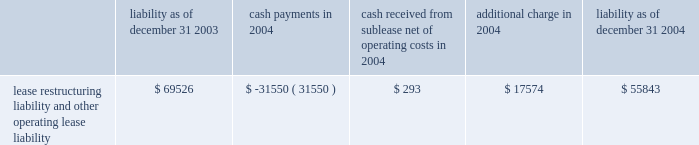The activity related to the restructuring liability for 2004 is as follows ( in thousands ) : non-operating items interest income increased $ 1.7 million to $ 12.0 million in 2005 from $ 10.3 million in 2004 .
The increase was mainly the result of higher returns on invested funds .
Interest expense decreased $ 1.0 million , or 5% ( 5 % ) , to $ 17.3 million in 2005 from $ 18.3 million in 2004 as a result of the exchange of newly issued stock for a portion of our outstanding convertible debt in the second half of 2005 .
In addition , as a result of the issuance during 2005 of common stock in exchange for convertible subordinated notes , we recorded a non- cash charge of $ 48.2 million .
This charge related to the incremental shares issued in the transactions over the number of shares that would have been issued upon the conversion of the notes under their original terms .
Liquidity and capital resources we have incurred operating losses since our inception and historically have financed our operations principally through public and private offerings of our equity and debt securities , strategic collaborative agreements that include research and/or development funding , development milestones and royalties on the sales of products , investment income and proceeds from the issuance of stock under our employee benefit programs .
At december 31 , 2006 , we had cash , cash equivalents and marketable securities of $ 761.8 million , which was an increase of $ 354.2 million from $ 407.5 million at december 31 , 2005 .
The increase was primarily a result of : 2022 $ 313.7 million in net proceeds from our september 2006 public offering of common stock ; 2022 $ 165.0 million from an up-front payment we received in connection with signing the janssen agreement ; 2022 $ 52.4 million from the issuance of common stock under our employee benefit plans ; and 2022 $ 30.0 million from the sale of shares of altus pharmaceuticals inc .
Common stock and warrants to purchase altus common stock .
These cash inflows were partially offset by the significant cash expenditures we made in 2006 related to research and development expenses and sales , general and administrative expenses .
Capital expenditures for property and equipment during 2006 were $ 32.4 million .
At december 31 , 2006 , we had $ 42.1 million in aggregate principal amount of the 2007 notes and $ 59.6 million in aggregate principal amount of the 2011 notes outstanding .
The 2007 notes are due in september 2007 and are convertible into common stock at the option of the holder at a price equal to $ 92.26 per share , subject to adjustment under certain circumstances .
In february 2007 , we announced that we will redeem our 2011 notes on march 5 , 2007 .
The 2011 notes are convertible into shares of our common stock at the option of the holder at a price equal to $ 14.94 per share .
We expect the holders of the 2011 notes will elect to convert their notes into stock , in which case we will issue approximately 4.0 million .
We will be required to repay any 2011 notes that are not converted at the rate of $ 1003.19 per $ 1000 principal amount , which includes principal and interest that will accrue to the redemption date .
Liability as of december 31 , payments in 2004 cash received from sublease , net of operating costs in 2004 additional charge in liability as of december 31 , lease restructuring liability and other operating lease liability $ 69526 $ ( 31550 ) $ 293 $ 17574 $ 55843 .
The activity related to the restructuring liability for 2004 is as follows ( in thousands ) : non-operating items interest income increased $ 1.7 million to $ 12.0 million in 2005 from $ 10.3 million in 2004 .
The increase was mainly the result of higher returns on invested funds .
Interest expense decreased $ 1.0 million , or 5% ( 5 % ) , to $ 17.3 million in 2005 from $ 18.3 million in 2004 as a result of the exchange of newly issued stock for a portion of our outstanding convertible debt in the second half of 2005 .
In addition , as a result of the issuance during 2005 of common stock in exchange for convertible subordinated notes , we recorded a non- cash charge of $ 48.2 million .
This charge related to the incremental shares issued in the transactions over the number of shares that would have been issued upon the conversion of the notes under their original terms .
Liquidity and capital resources we have incurred operating losses since our inception and historically have financed our operations principally through public and private offerings of our equity and debt securities , strategic collaborative agreements that include research and/or development funding , development milestones and royalties on the sales of products , investment income and proceeds from the issuance of stock under our employee benefit programs .
At december 31 , 2006 , we had cash , cash equivalents and marketable securities of $ 761.8 million , which was an increase of $ 354.2 million from $ 407.5 million at december 31 , 2005 .
The increase was primarily a result of : 2022 $ 313.7 million in net proceeds from our september 2006 public offering of common stock ; 2022 $ 165.0 million from an up-front payment we received in connection with signing the janssen agreement ; 2022 $ 52.4 million from the issuance of common stock under our employee benefit plans ; and 2022 $ 30.0 million from the sale of shares of altus pharmaceuticals inc .
Common stock and warrants to purchase altus common stock .
These cash inflows were partially offset by the significant cash expenditures we made in 2006 related to research and development expenses and sales , general and administrative expenses .
Capital expenditures for property and equipment during 2006 were $ 32.4 million .
At december 31 , 2006 , we had $ 42.1 million in aggregate principal amount of the 2007 notes and $ 59.6 million in aggregate principal amount of the 2011 notes outstanding .
The 2007 notes are due in september 2007 and are convertible into common stock at the option of the holder at a price equal to $ 92.26 per share , subject to adjustment under certain circumstances .
In february 2007 , we announced that we will redeem our 2011 notes on march 5 , 2007 .
The 2011 notes are convertible into shares of our common stock at the option of the holder at a price equal to $ 14.94 per share .
We expect the holders of the 2011 notes will elect to convert their notes into stock , in which case we will issue approximately 4.0 million .
We will be required to repay any 2011 notes that are not converted at the rate of $ 1003.19 per $ 1000 principal amount , which includes principal and interest that will accrue to the redemption date .
Liability as of december 31 , payments in 2004 cash received from sublease , net of operating costs in 2004 additional charge in liability as of december 31 , lease restructuring liability and other operating lease liability $ 69526 $ ( 31550 ) $ 293 $ 17574 $ 55843 .
What is the percent change in cash , cash equivalents and marketable securities between 2005 and 2006? 
Rationale: there is something wrong with this sample . i think it is repeated but i'm not sure .
Computations: ((761.8 - 407.5) / 407.5)
Answer: 0.86945. The activity related to the restructuring liability for 2004 is as follows ( in thousands ) : non-operating items interest income increased $ 1.7 million to $ 12.0 million in 2005 from $ 10.3 million in 2004 .
The increase was mainly the result of higher returns on invested funds .
Interest expense decreased $ 1.0 million , or 5% ( 5 % ) , to $ 17.3 million in 2005 from $ 18.3 million in 2004 as a result of the exchange of newly issued stock for a portion of our outstanding convertible debt in the second half of 2005 .
In addition , as a result of the issuance during 2005 of common stock in exchange for convertible subordinated notes , we recorded a non- cash charge of $ 48.2 million .
This charge related to the incremental shares issued in the transactions over the number of shares that would have been issued upon the conversion of the notes under their original terms .
Liquidity and capital resources we have incurred operating losses since our inception and historically have financed our operations principally through public and private offerings of our equity and debt securities , strategic collaborative agreements that include research and/or development funding , development milestones and royalties on the sales of products , investment income and proceeds from the issuance of stock under our employee benefit programs .
At december 31 , 2006 , we had cash , cash equivalents and marketable securities of $ 761.8 million , which was an increase of $ 354.2 million from $ 407.5 million at december 31 , 2005 .
The increase was primarily a result of : 2022 $ 313.7 million in net proceeds from our september 2006 public offering of common stock ; 2022 $ 165.0 million from an up-front payment we received in connection with signing the janssen agreement ; 2022 $ 52.4 million from the issuance of common stock under our employee benefit plans ; and 2022 $ 30.0 million from the sale of shares of altus pharmaceuticals inc .
Common stock and warrants to purchase altus common stock .
These cash inflows were partially offset by the significant cash expenditures we made in 2006 related to research and development expenses and sales , general and administrative expenses .
Capital expenditures for property and equipment during 2006 were $ 32.4 million .
At december 31 , 2006 , we had $ 42.1 million in aggregate principal amount of the 2007 notes and $ 59.6 million in aggregate principal amount of the 2011 notes outstanding .
The 2007 notes are due in september 2007 and are convertible into common stock at the option of the holder at a price equal to $ 92.26 per share , subject to adjustment under certain circumstances .
In february 2007 , we announced that we will redeem our 2011 notes on march 5 , 2007 .
The 2011 notes are convertible into shares of our common stock at the option of the holder at a price equal to $ 14.94 per share .
We expect the holders of the 2011 notes will elect to convert their notes into stock , in which case we will issue approximately 4.0 million .
We will be required to repay any 2011 notes that are not converted at the rate of $ 1003.19 per $ 1000 principal amount , which includes principal and interest that will accrue to the redemption date .
Liability as of december 31 , payments in 2004 cash received from sublease , net of operating costs in 2004 additional charge in liability as of december 31 , lease restructuring liability and other operating lease liability $ 69526 $ ( 31550 ) $ 293 $ 17574 $ 55843 .
The activity related to the restructuring liability for 2004 is as follows ( in thousands ) : non-operating items interest income increased $ 1.7 million to $ 12.0 million in 2005 from $ 10.3 million in 2004 .
The increase was mainly the result of higher returns on invested funds .
Interest expense decreased $ 1.0 million , or 5% ( 5 % ) , to $ 17.3 million in 2005 from $ 18.3 million in 2004 as a result of the exchange of newly issued stock for a portion of our outstanding convertible debt in the second half of 2005 .
In addition , as a result of the issuance during 2005 of common stock in exchange for convertible subordinated notes , we recorded a non- cash charge of $ 48.2 million .
This charge related to the incremental shares issued in the transactions over the number of shares that would have been issued upon the conversion of the notes under their original terms .
Liquidity and capital resources we have incurred operating losses since our inception and historically have financed our operations principally through public and private offerings of our equity and debt securities , strategic collaborative agreements that include research and/or development funding , development milestones and royalties on the sales of products , investment income and proceeds from the issuance of stock under our employee benefit programs .
At december 31 , 2006 , we had cash , cash equivalents and marketable securities of $ 761.8 million , which was an increase of $ 354.2 million from $ 407.5 million at december 31 , 2005 .
The increase was primarily a result of : 2022 $ 313.7 million in net proceeds from our september 2006 public offering of common stock ; 2022 $ 165.0 million from an up-front payment we received in connection with signing the janssen agreement ; 2022 $ 52.4 million from the issuance of common stock under our employee benefit plans ; and 2022 $ 30.0 million from the sale of shares of altus pharmaceuticals inc .
Common stock and warrants to purchase altus common stock .
These cash inflows were partially offset by the significant cash expenditures we made in 2006 related to research and development expenses and sales , general and administrative expenses .
Capital expenditures for property and equipment during 2006 were $ 32.4 million .
At december 31 , 2006 , we had $ 42.1 million in aggregate principal amount of the 2007 notes and $ 59.6 million in aggregate principal amount of the 2011 notes outstanding .
The 2007 notes are due in september 2007 and are convertible into common stock at the option of the holder at a price equal to $ 92.26 per share , subject to adjustment under certain circumstances .
In february 2007 , we announced that we will redeem our 2011 notes on march 5 , 2007 .
The 2011 notes are convertible into shares of our common stock at the option of the holder at a price equal to $ 14.94 per share .
We expect the holders of the 2011 notes will elect to convert their notes into stock , in which case we will issue approximately 4.0 million .
We will be required to repay any 2011 notes that are not converted at the rate of $ 1003.19 per $ 1000 principal amount , which includes principal and interest that will accrue to the redemption date .
Liability as of december 31 , payments in 2004 cash received from sublease , net of operating costs in 2004 additional charge in liability as of december 31 , lease restructuring liability and other operating lease liability $ 69526 $ ( 31550 ) $ 293 $ 17574 $ 55843 .
What was the change in the lease restructuring liability and other operating lease liability in 2004? 
Computations: (55843 - 69526)
Answer: -13683.0. 